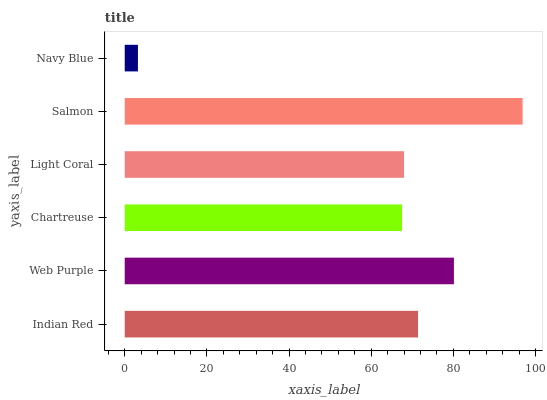Is Navy Blue the minimum?
Answer yes or no. Yes. Is Salmon the maximum?
Answer yes or no. Yes. Is Web Purple the minimum?
Answer yes or no. No. Is Web Purple the maximum?
Answer yes or no. No. Is Web Purple greater than Indian Red?
Answer yes or no. Yes. Is Indian Red less than Web Purple?
Answer yes or no. Yes. Is Indian Red greater than Web Purple?
Answer yes or no. No. Is Web Purple less than Indian Red?
Answer yes or no. No. Is Indian Red the high median?
Answer yes or no. Yes. Is Light Coral the low median?
Answer yes or no. Yes. Is Web Purple the high median?
Answer yes or no. No. Is Web Purple the low median?
Answer yes or no. No. 